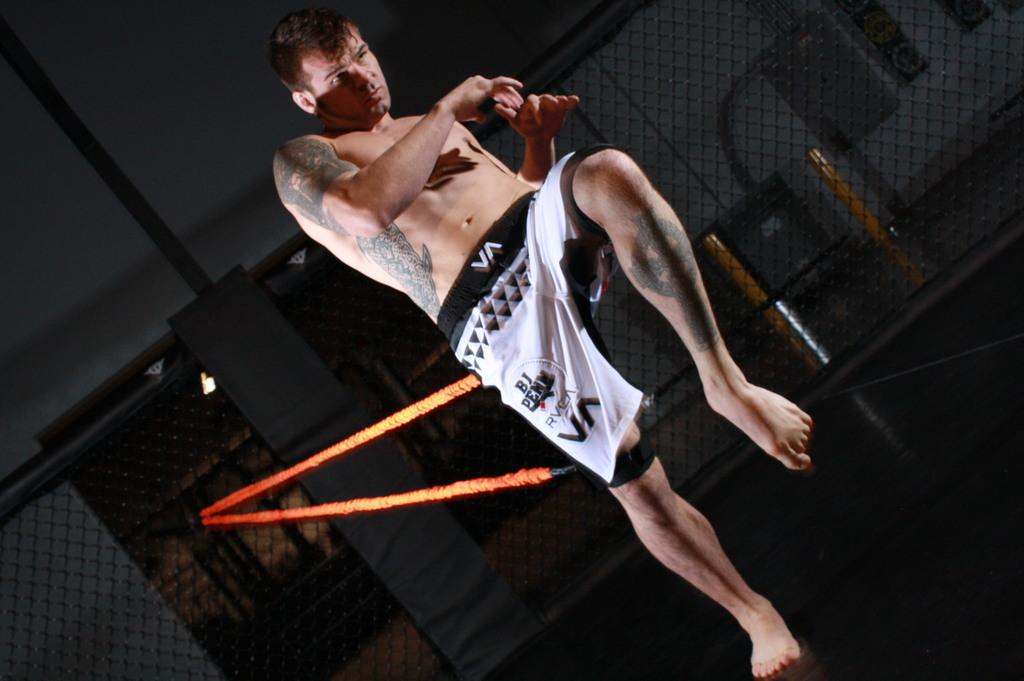<image>
Offer a succinct explanation of the picture presented. A man in shorts that say RVEA practices martial arts. 